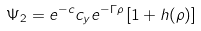Convert formula to latex. <formula><loc_0><loc_0><loc_500><loc_500>\Psi _ { 2 } = e ^ { - c } c _ { y } e ^ { - \Gamma \rho } \left [ 1 + h ( \rho ) \right ]</formula> 